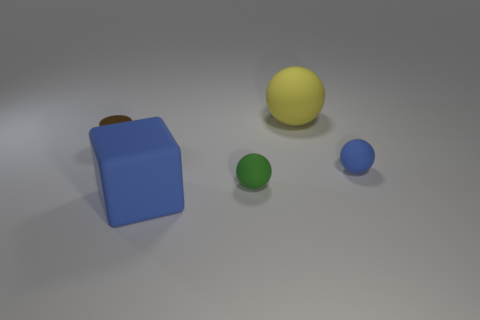Are there more small blue matte spheres to the right of the tiny metal thing than brown things right of the yellow ball?
Make the answer very short. Yes. What number of other things are there of the same size as the cylinder?
Offer a very short reply. 2. The object that is both left of the yellow rubber object and behind the tiny green matte thing is made of what material?
Give a very brief answer. Metal. There is a tiny green thing in front of the matte sphere that is behind the tiny brown metallic cylinder; what number of matte balls are to the right of it?
Offer a terse response. 2. Are there any other things that are the same color as the metallic object?
Your answer should be compact. No. How many objects are to the left of the yellow ball and in front of the brown metallic thing?
Provide a succinct answer. 2. There is a ball that is behind the small blue rubber object; is its size the same as the brown metallic cylinder behind the small blue ball?
Your response must be concise. No. How many things are big matte things that are behind the brown metallic thing or large yellow things?
Your answer should be very brief. 1. There is a big object to the right of the large blue matte object; what is it made of?
Give a very brief answer. Rubber. What is the material of the tiny blue sphere?
Your answer should be compact. Rubber. 